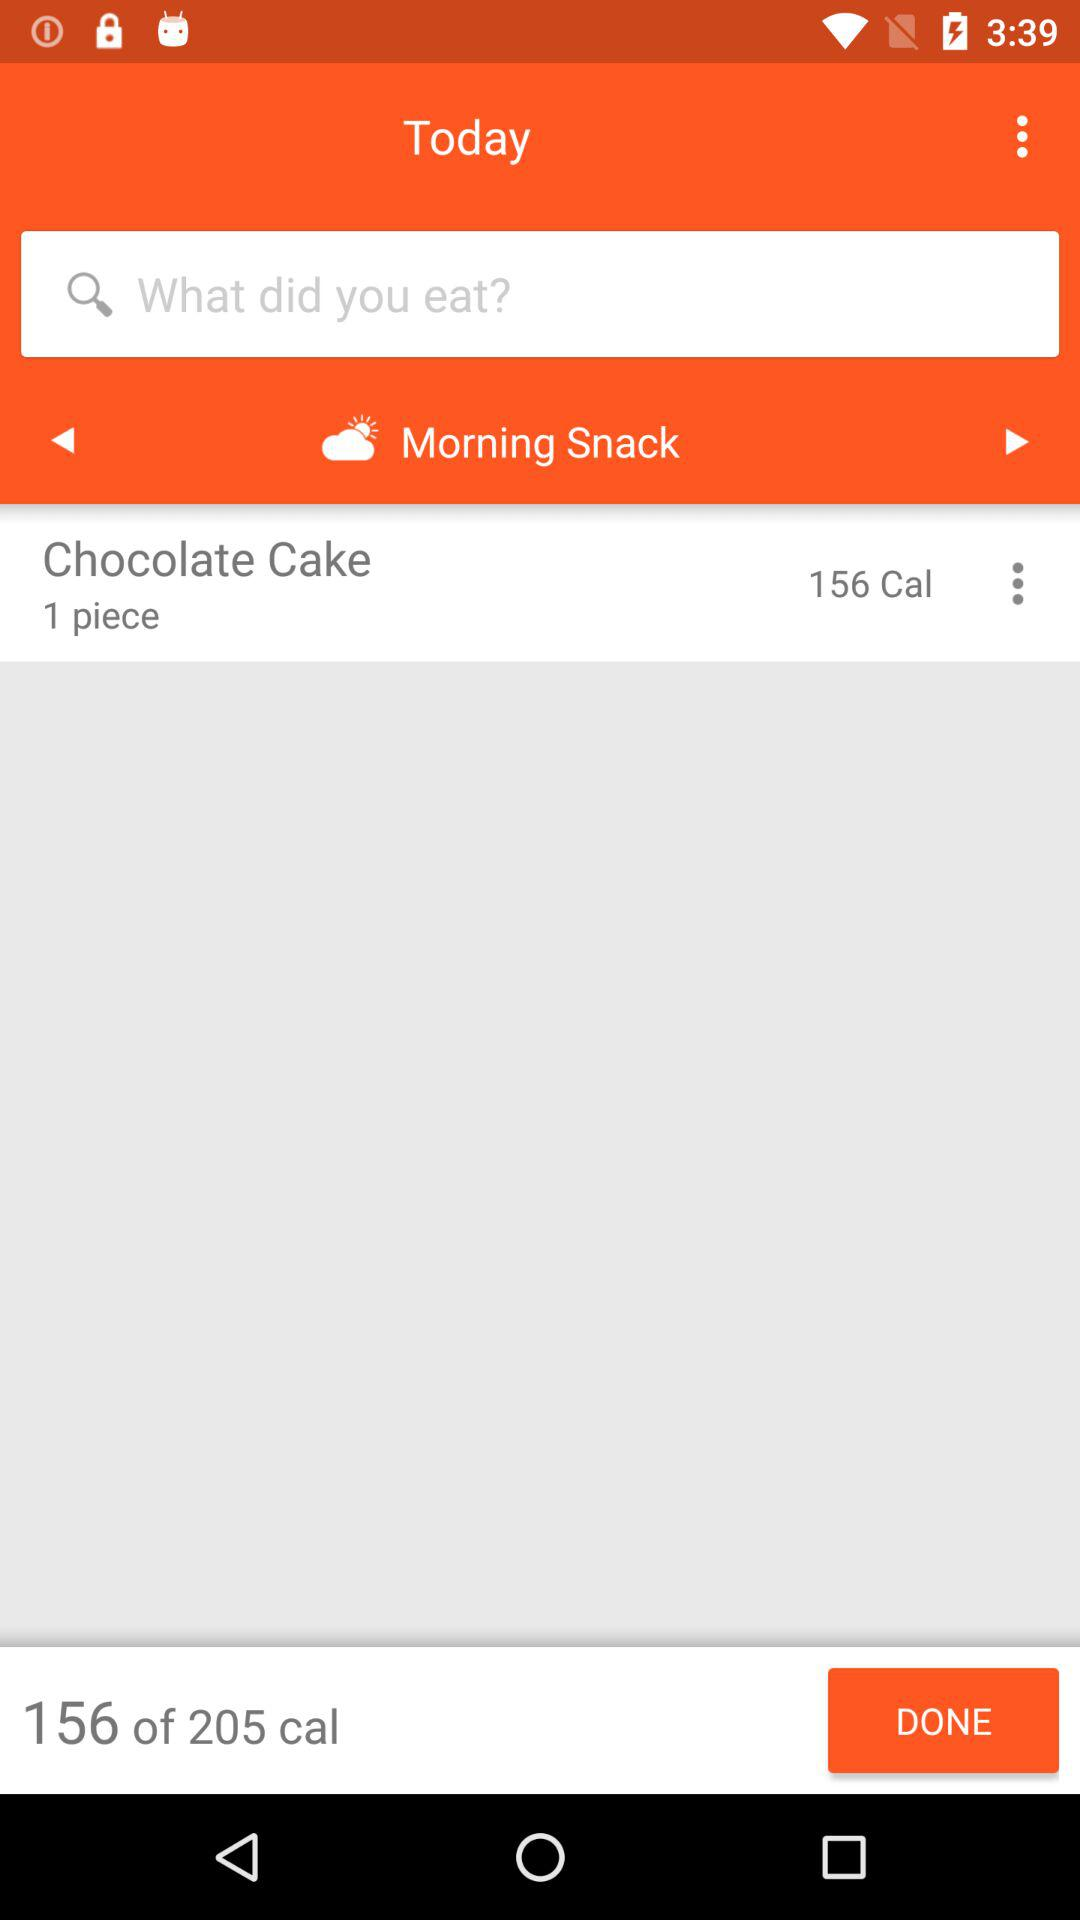How many calories are in "Chocolate Cake"? There are 156 calories. 